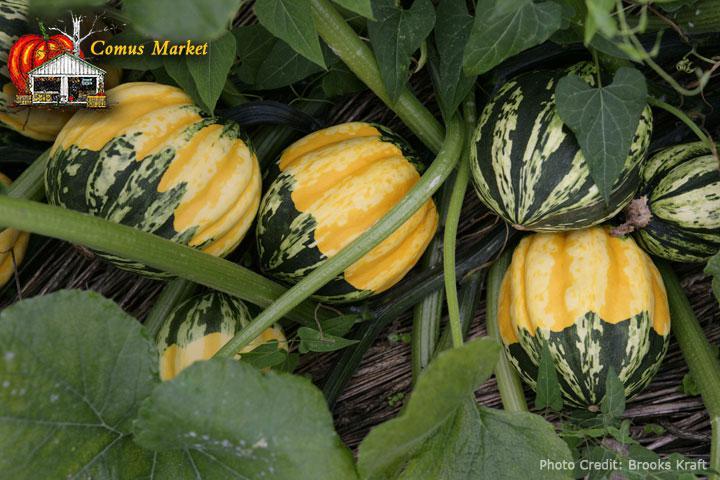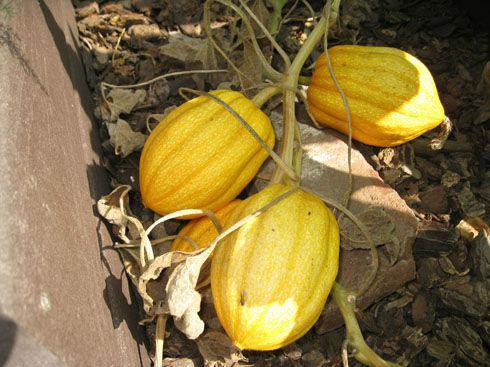The first image is the image on the left, the second image is the image on the right. Examine the images to the left and right. Is the description "The left image includes multiple squash with yellow tops and green variegated bottoms and does not include any solid colored squash." accurate? Answer yes or no. Yes. 